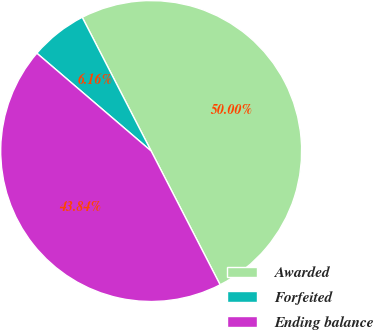Convert chart to OTSL. <chart><loc_0><loc_0><loc_500><loc_500><pie_chart><fcel>Awarded<fcel>Forfeited<fcel>Ending balance<nl><fcel>50.0%<fcel>6.16%<fcel>43.84%<nl></chart> 